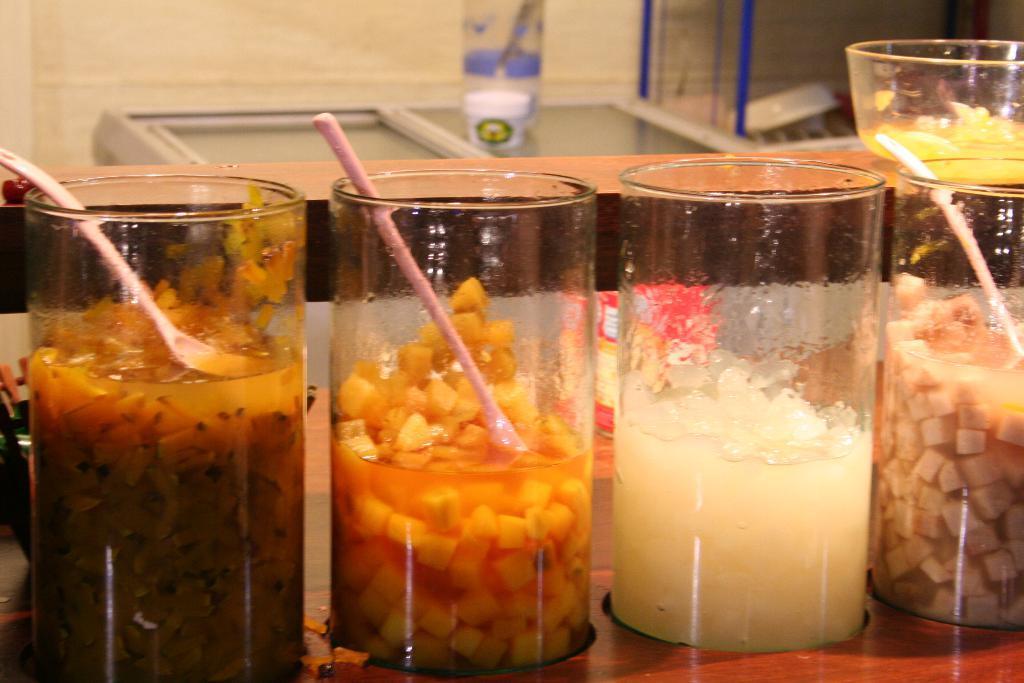Could you give a brief overview of what you see in this image? In this image there are tables on that tables there are glasses, in that glasses there is food item and spoons, in the background there is fridge on that fridge there is a bottle. 